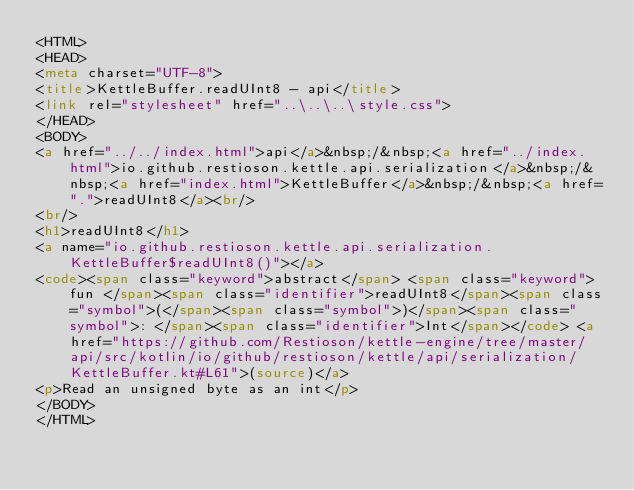Convert code to text. <code><loc_0><loc_0><loc_500><loc_500><_HTML_><HTML>
<HEAD>
<meta charset="UTF-8">
<title>KettleBuffer.readUInt8 - api</title>
<link rel="stylesheet" href="..\..\..\style.css">
</HEAD>
<BODY>
<a href="../../index.html">api</a>&nbsp;/&nbsp;<a href="../index.html">io.github.restioson.kettle.api.serialization</a>&nbsp;/&nbsp;<a href="index.html">KettleBuffer</a>&nbsp;/&nbsp;<a href=".">readUInt8</a><br/>
<br/>
<h1>readUInt8</h1>
<a name="io.github.restioson.kettle.api.serialization.KettleBuffer$readUInt8()"></a>
<code><span class="keyword">abstract</span> <span class="keyword">fun </span><span class="identifier">readUInt8</span><span class="symbol">(</span><span class="symbol">)</span><span class="symbol">: </span><span class="identifier">Int</span></code> <a href="https://github.com/Restioson/kettle-engine/tree/master/api/src/kotlin/io/github/restioson/kettle/api/serialization/KettleBuffer.kt#L61">(source)</a>
<p>Read an unsigned byte as an int</p>
</BODY>
</HTML>
</code> 